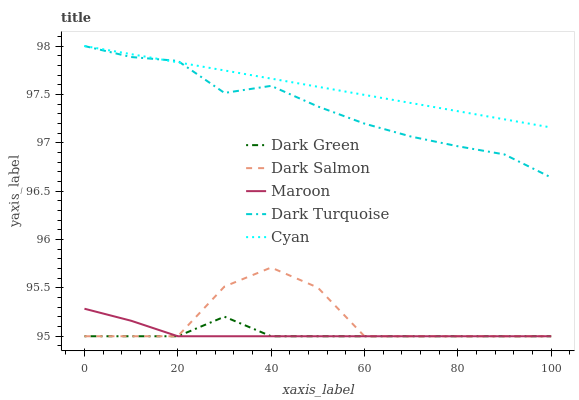Does Dark Salmon have the minimum area under the curve?
Answer yes or no. No. Does Dark Salmon have the maximum area under the curve?
Answer yes or no. No. Is Dark Salmon the smoothest?
Answer yes or no. No. Is Cyan the roughest?
Answer yes or no. No. Does Cyan have the lowest value?
Answer yes or no. No. Does Dark Salmon have the highest value?
Answer yes or no. No. Is Maroon less than Cyan?
Answer yes or no. Yes. Is Cyan greater than Dark Green?
Answer yes or no. Yes. Does Maroon intersect Cyan?
Answer yes or no. No. 